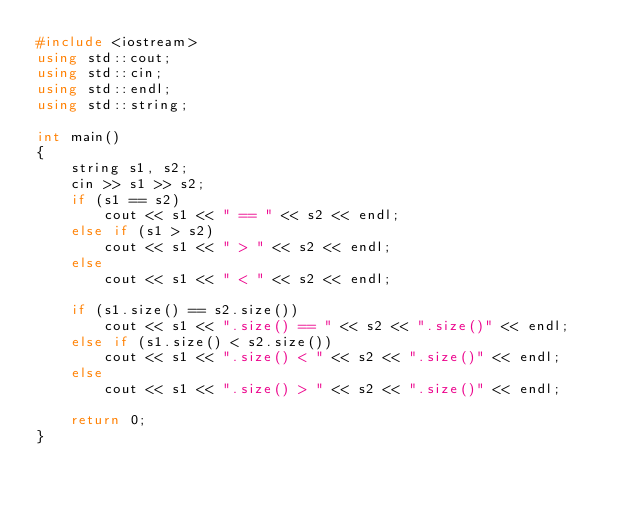Convert code to text. <code><loc_0><loc_0><loc_500><loc_500><_C++_>#include <iostream>
using std::cout;
using std::cin;
using std::endl;
using std::string;

int main()
{
    string s1, s2;
    cin >> s1 >> s2;
    if (s1 == s2)
        cout << s1 << " == " << s2 << endl;
    else if (s1 > s2)
        cout << s1 << " > " << s2 << endl;
    else
        cout << s1 << " < " << s2 << endl;
    
    if (s1.size() == s2.size())
        cout << s1 << ".size() == " << s2 << ".size()" << endl;
    else if (s1.size() < s2.size())
        cout << s1 << ".size() < " << s2 << ".size()" << endl;
    else
        cout << s1 << ".size() > " << s2 << ".size()" << endl;

    return 0;
}</code> 